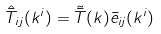<formula> <loc_0><loc_0><loc_500><loc_500>\hat { \bar { T } } _ { i j } ( k ^ { i } ) = \tilde { \bar { T } } ( k ) \bar { e } _ { i j } ( k ^ { i } )</formula> 